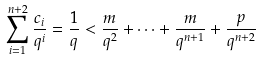<formula> <loc_0><loc_0><loc_500><loc_500>\sum _ { i = 1 } ^ { n + 2 } \frac { c _ { i } } { q ^ { i } } = \frac { 1 } { q } < \frac { m } { q ^ { 2 } } + \cdots + \frac { m } { q ^ { n + 1 } } + \frac { p } { q ^ { n + 2 } }</formula> 